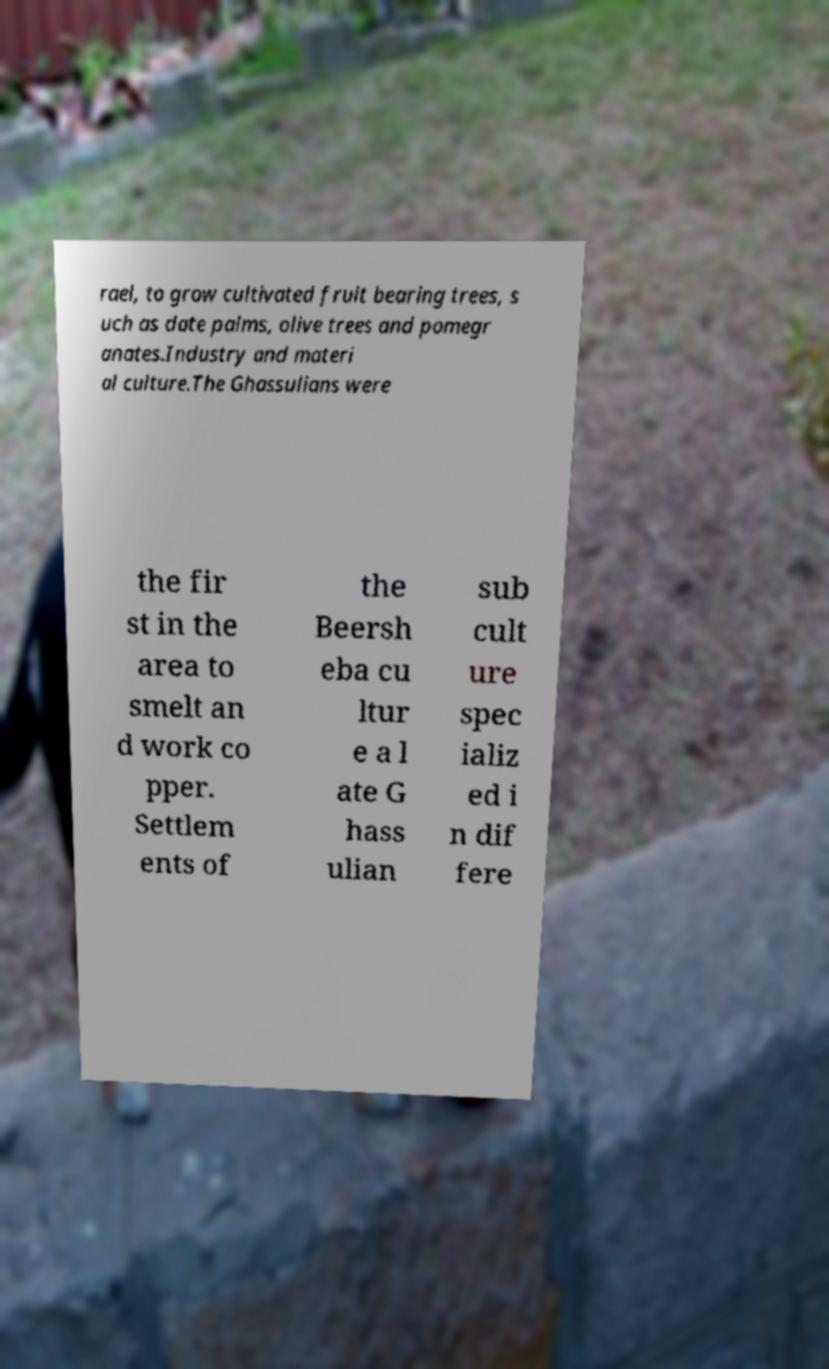Can you accurately transcribe the text from the provided image for me? rael, to grow cultivated fruit bearing trees, s uch as date palms, olive trees and pomegr anates.Industry and materi al culture.The Ghassulians were the fir st in the area to smelt an d work co pper. Settlem ents of the Beersh eba cu ltur e a l ate G hass ulian sub cult ure spec ializ ed i n dif fere 